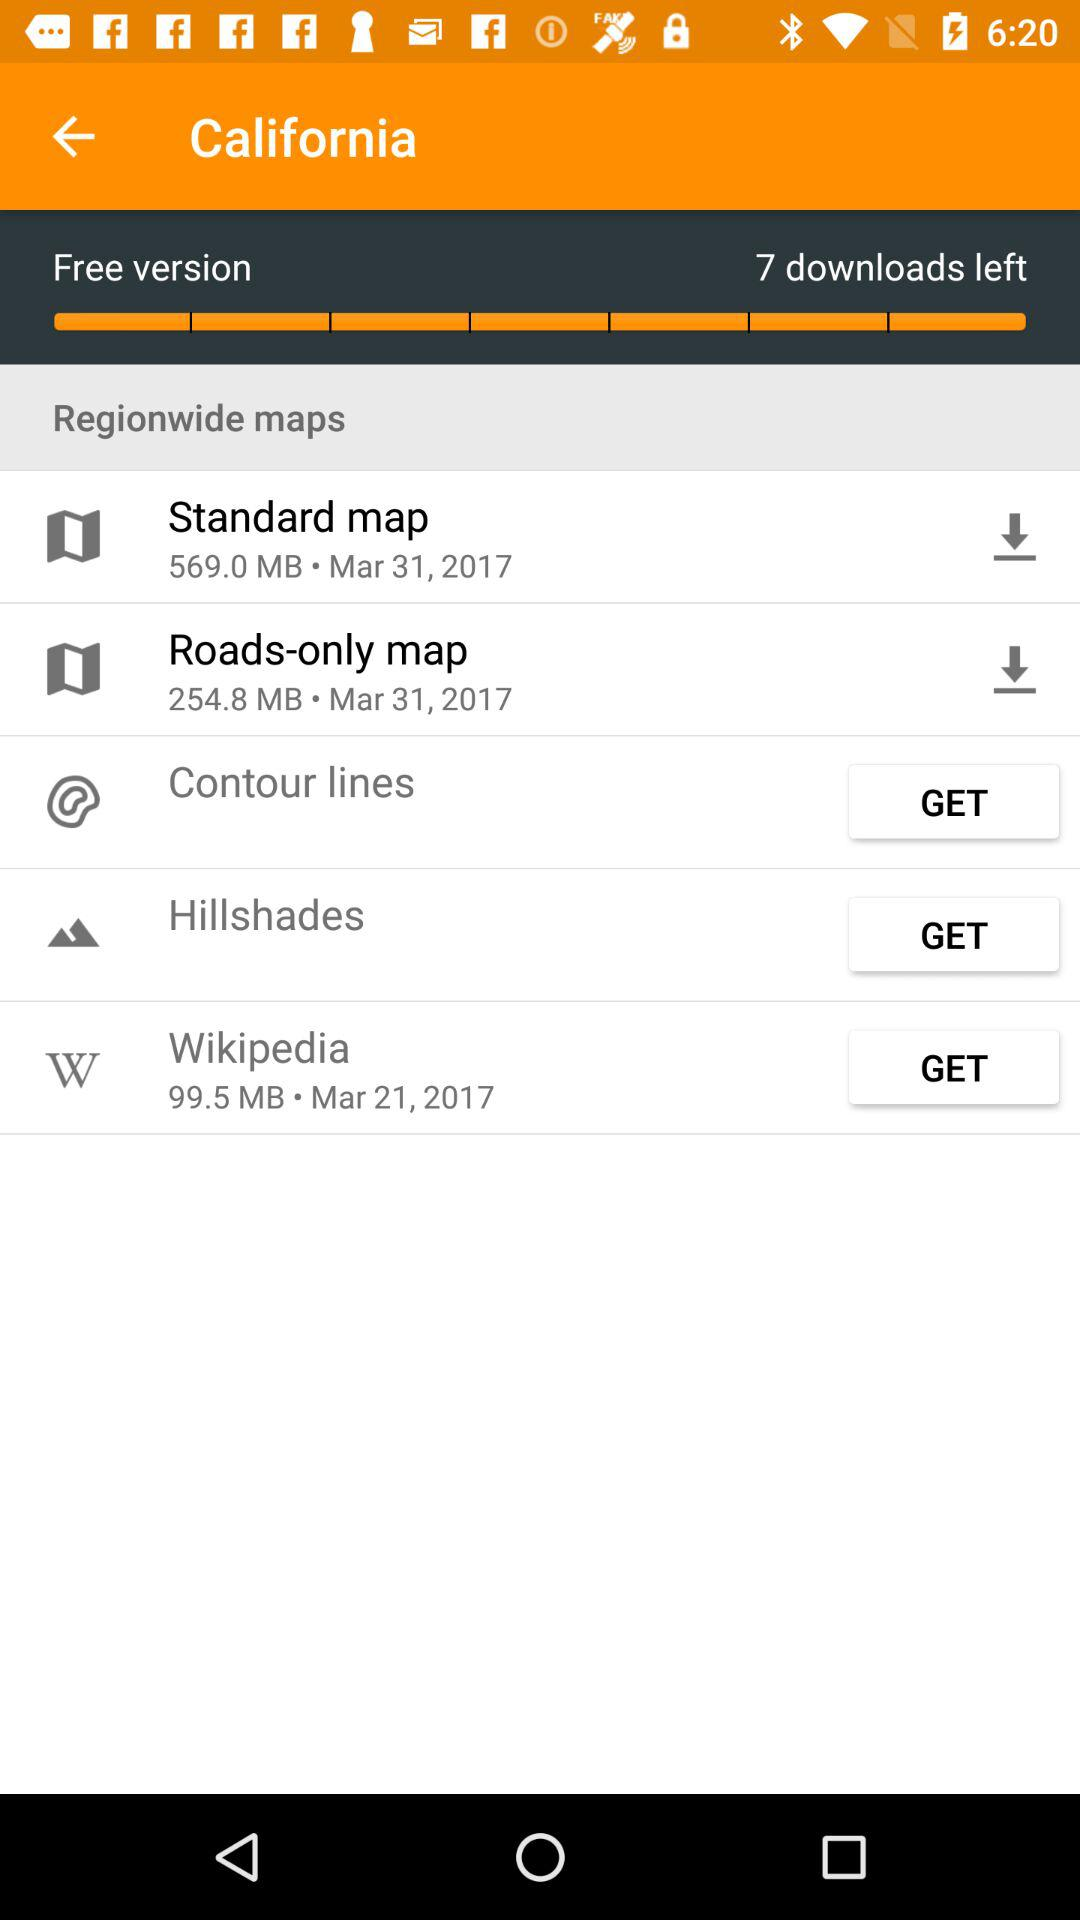What is the date for "Standard map"? The date is March 31, 2017. 